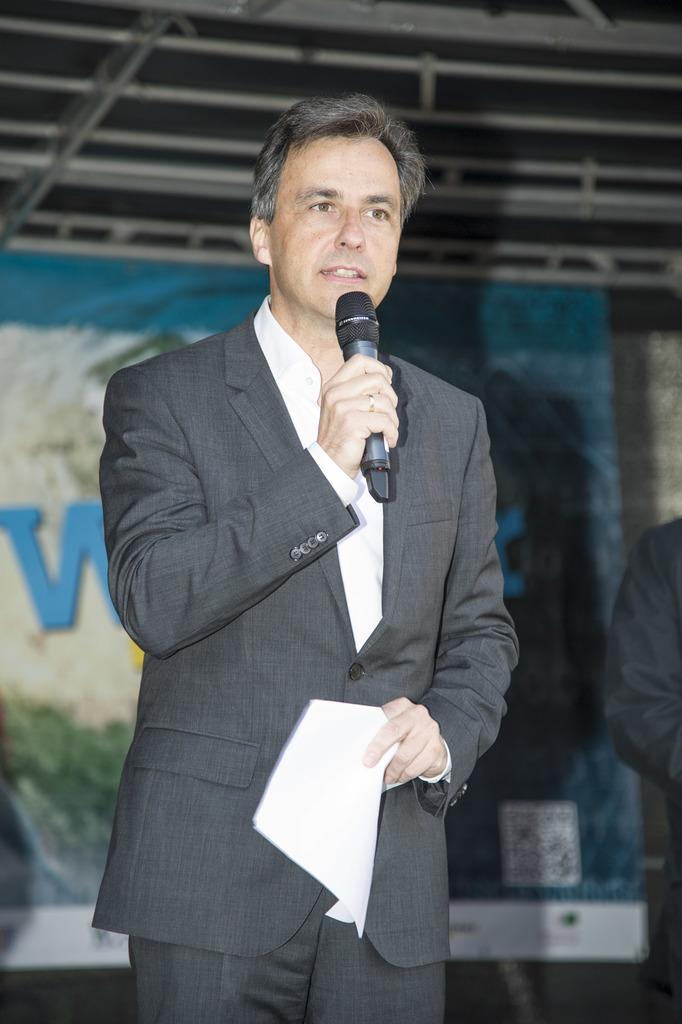Who is the main subject in the picture? There is a man in the picture. What is the man holding in his hand? The man is holding a microphone in his hand. What else is the man holding? The man is holding some papers. What is the man wearing? The man is wearing a coat. What is the man doing in the picture? The man is talking. What type of pump is visible in the image? There is no pump present in the image. How does the man's disease affect his ability to talk in the image? There is no mention of a disease affecting the man in the image. 